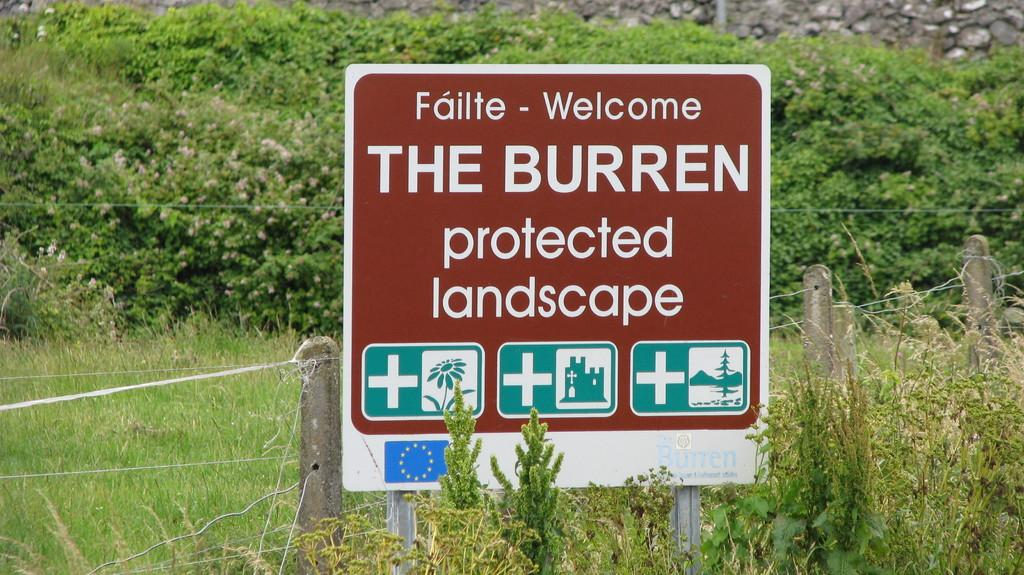<image>
Give a short and clear explanation of the subsequent image. A sign in a wooded area offers a welcome message to an area of protected landscape. 